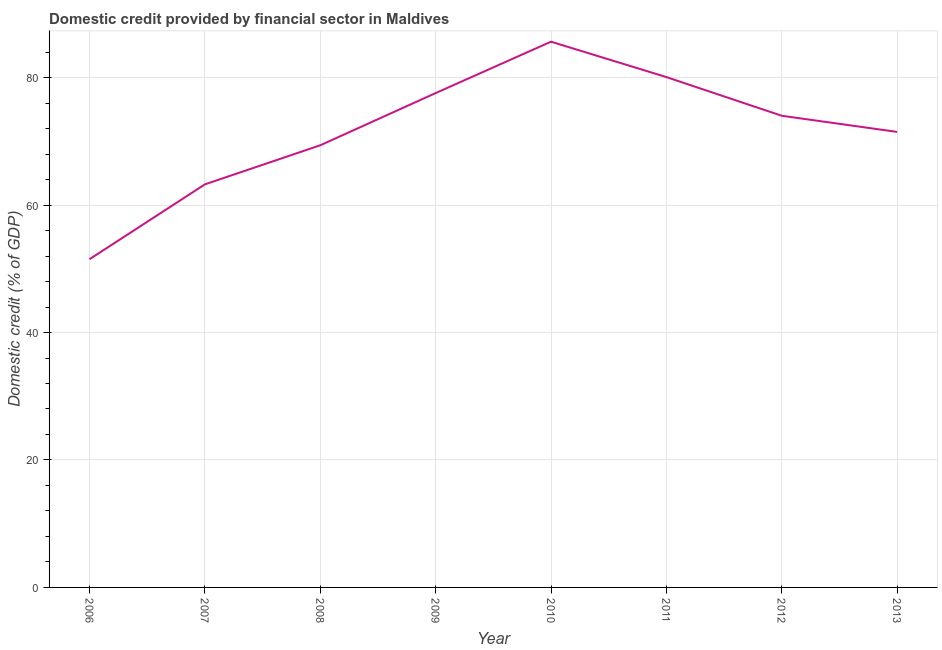What is the domestic credit provided by financial sector in 2009?
Your response must be concise. 77.58. Across all years, what is the maximum domestic credit provided by financial sector?
Your response must be concise. 85.64. Across all years, what is the minimum domestic credit provided by financial sector?
Your answer should be very brief. 51.5. In which year was the domestic credit provided by financial sector maximum?
Make the answer very short. 2010. What is the sum of the domestic credit provided by financial sector?
Offer a terse response. 572.94. What is the difference between the domestic credit provided by financial sector in 2011 and 2013?
Offer a terse response. 8.61. What is the average domestic credit provided by financial sector per year?
Your response must be concise. 71.62. What is the median domestic credit provided by financial sector?
Your answer should be very brief. 72.75. In how many years, is the domestic credit provided by financial sector greater than 72 %?
Ensure brevity in your answer.  4. Do a majority of the years between 2009 and 2008 (inclusive) have domestic credit provided by financial sector greater than 40 %?
Your answer should be compact. No. What is the ratio of the domestic credit provided by financial sector in 2006 to that in 2013?
Make the answer very short. 0.72. What is the difference between the highest and the second highest domestic credit provided by financial sector?
Offer a very short reply. 5.55. Is the sum of the domestic credit provided by financial sector in 2008 and 2012 greater than the maximum domestic credit provided by financial sector across all years?
Your answer should be compact. Yes. What is the difference between the highest and the lowest domestic credit provided by financial sector?
Keep it short and to the point. 34.13. In how many years, is the domestic credit provided by financial sector greater than the average domestic credit provided by financial sector taken over all years?
Your answer should be very brief. 4. How many lines are there?
Provide a succinct answer. 1. Does the graph contain any zero values?
Ensure brevity in your answer.  No. What is the title of the graph?
Keep it short and to the point. Domestic credit provided by financial sector in Maldives. What is the label or title of the Y-axis?
Provide a short and direct response. Domestic credit (% of GDP). What is the Domestic credit (% of GDP) in 2006?
Your answer should be very brief. 51.5. What is the Domestic credit (% of GDP) in 2007?
Your answer should be very brief. 63.25. What is the Domestic credit (% of GDP) in 2008?
Offer a very short reply. 69.38. What is the Domestic credit (% of GDP) of 2009?
Offer a very short reply. 77.58. What is the Domestic credit (% of GDP) of 2010?
Provide a short and direct response. 85.64. What is the Domestic credit (% of GDP) in 2011?
Provide a succinct answer. 80.09. What is the Domestic credit (% of GDP) in 2012?
Your answer should be very brief. 74.02. What is the Domestic credit (% of GDP) of 2013?
Offer a terse response. 71.48. What is the difference between the Domestic credit (% of GDP) in 2006 and 2007?
Keep it short and to the point. -11.75. What is the difference between the Domestic credit (% of GDP) in 2006 and 2008?
Make the answer very short. -17.88. What is the difference between the Domestic credit (% of GDP) in 2006 and 2009?
Make the answer very short. -26.07. What is the difference between the Domestic credit (% of GDP) in 2006 and 2010?
Your answer should be compact. -34.13. What is the difference between the Domestic credit (% of GDP) in 2006 and 2011?
Your response must be concise. -28.58. What is the difference between the Domestic credit (% of GDP) in 2006 and 2012?
Offer a very short reply. -22.51. What is the difference between the Domestic credit (% of GDP) in 2006 and 2013?
Make the answer very short. -19.98. What is the difference between the Domestic credit (% of GDP) in 2007 and 2008?
Give a very brief answer. -6.13. What is the difference between the Domestic credit (% of GDP) in 2007 and 2009?
Offer a very short reply. -14.33. What is the difference between the Domestic credit (% of GDP) in 2007 and 2010?
Give a very brief answer. -22.39. What is the difference between the Domestic credit (% of GDP) in 2007 and 2011?
Provide a short and direct response. -16.84. What is the difference between the Domestic credit (% of GDP) in 2007 and 2012?
Keep it short and to the point. -10.77. What is the difference between the Domestic credit (% of GDP) in 2007 and 2013?
Provide a succinct answer. -8.23. What is the difference between the Domestic credit (% of GDP) in 2008 and 2009?
Your response must be concise. -8.19. What is the difference between the Domestic credit (% of GDP) in 2008 and 2010?
Give a very brief answer. -16.26. What is the difference between the Domestic credit (% of GDP) in 2008 and 2011?
Your answer should be very brief. -10.71. What is the difference between the Domestic credit (% of GDP) in 2008 and 2012?
Your answer should be compact. -4.63. What is the difference between the Domestic credit (% of GDP) in 2008 and 2013?
Your response must be concise. -2.1. What is the difference between the Domestic credit (% of GDP) in 2009 and 2010?
Provide a succinct answer. -8.06. What is the difference between the Domestic credit (% of GDP) in 2009 and 2011?
Offer a terse response. -2.51. What is the difference between the Domestic credit (% of GDP) in 2009 and 2012?
Your answer should be compact. 3.56. What is the difference between the Domestic credit (% of GDP) in 2009 and 2013?
Ensure brevity in your answer.  6.09. What is the difference between the Domestic credit (% of GDP) in 2010 and 2011?
Your answer should be compact. 5.55. What is the difference between the Domestic credit (% of GDP) in 2010 and 2012?
Offer a terse response. 11.62. What is the difference between the Domestic credit (% of GDP) in 2010 and 2013?
Make the answer very short. 14.16. What is the difference between the Domestic credit (% of GDP) in 2011 and 2012?
Offer a terse response. 6.07. What is the difference between the Domestic credit (% of GDP) in 2011 and 2013?
Give a very brief answer. 8.61. What is the difference between the Domestic credit (% of GDP) in 2012 and 2013?
Offer a terse response. 2.53. What is the ratio of the Domestic credit (% of GDP) in 2006 to that in 2007?
Keep it short and to the point. 0.81. What is the ratio of the Domestic credit (% of GDP) in 2006 to that in 2008?
Provide a short and direct response. 0.74. What is the ratio of the Domestic credit (% of GDP) in 2006 to that in 2009?
Ensure brevity in your answer.  0.66. What is the ratio of the Domestic credit (% of GDP) in 2006 to that in 2010?
Provide a short and direct response. 0.6. What is the ratio of the Domestic credit (% of GDP) in 2006 to that in 2011?
Make the answer very short. 0.64. What is the ratio of the Domestic credit (% of GDP) in 2006 to that in 2012?
Provide a succinct answer. 0.7. What is the ratio of the Domestic credit (% of GDP) in 2006 to that in 2013?
Your answer should be compact. 0.72. What is the ratio of the Domestic credit (% of GDP) in 2007 to that in 2008?
Provide a succinct answer. 0.91. What is the ratio of the Domestic credit (% of GDP) in 2007 to that in 2009?
Your answer should be compact. 0.81. What is the ratio of the Domestic credit (% of GDP) in 2007 to that in 2010?
Ensure brevity in your answer.  0.74. What is the ratio of the Domestic credit (% of GDP) in 2007 to that in 2011?
Ensure brevity in your answer.  0.79. What is the ratio of the Domestic credit (% of GDP) in 2007 to that in 2012?
Make the answer very short. 0.85. What is the ratio of the Domestic credit (% of GDP) in 2007 to that in 2013?
Your answer should be very brief. 0.89. What is the ratio of the Domestic credit (% of GDP) in 2008 to that in 2009?
Keep it short and to the point. 0.89. What is the ratio of the Domestic credit (% of GDP) in 2008 to that in 2010?
Keep it short and to the point. 0.81. What is the ratio of the Domestic credit (% of GDP) in 2008 to that in 2011?
Make the answer very short. 0.87. What is the ratio of the Domestic credit (% of GDP) in 2008 to that in 2012?
Offer a very short reply. 0.94. What is the ratio of the Domestic credit (% of GDP) in 2009 to that in 2010?
Your response must be concise. 0.91. What is the ratio of the Domestic credit (% of GDP) in 2009 to that in 2012?
Your answer should be compact. 1.05. What is the ratio of the Domestic credit (% of GDP) in 2009 to that in 2013?
Provide a short and direct response. 1.08. What is the ratio of the Domestic credit (% of GDP) in 2010 to that in 2011?
Offer a terse response. 1.07. What is the ratio of the Domestic credit (% of GDP) in 2010 to that in 2012?
Keep it short and to the point. 1.16. What is the ratio of the Domestic credit (% of GDP) in 2010 to that in 2013?
Your response must be concise. 1.2. What is the ratio of the Domestic credit (% of GDP) in 2011 to that in 2012?
Offer a terse response. 1.08. What is the ratio of the Domestic credit (% of GDP) in 2011 to that in 2013?
Make the answer very short. 1.12. What is the ratio of the Domestic credit (% of GDP) in 2012 to that in 2013?
Offer a very short reply. 1.03. 